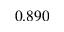Convert formula to latex. <formula><loc_0><loc_0><loc_500><loc_500>0 . 8 9 0</formula> 